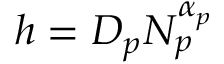Convert formula to latex. <formula><loc_0><loc_0><loc_500><loc_500>h = D _ { p } N _ { p } ^ { \alpha _ { p } }</formula> 